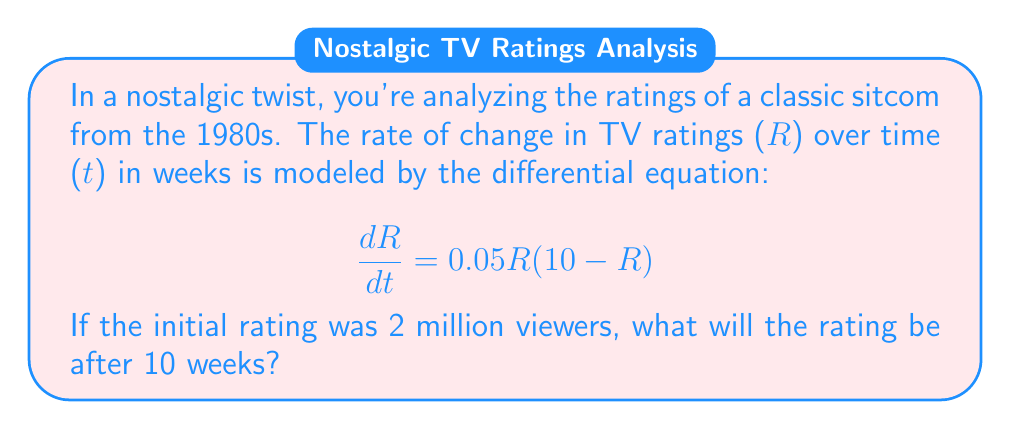Could you help me with this problem? To solve this problem, we need to use the separation of variables method for first-order differential equations. Let's break it down step-by-step:

1) First, we separate the variables:

   $$\frac{dR}{R(10-R)} = 0.05dt$$

2) Integrate both sides:

   $$\int \frac{dR}{R(10-R)} = \int 0.05dt$$

3) The left side can be integrated using partial fractions:

   $$\frac{1}{10}\ln|R| - \frac{1}{10}\ln|10-R| = 0.05t + C$$

4) Simplify:

   $$\ln|\frac{R}{10-R}| = 0.5t + C$$

5) Take the exponential of both sides:

   $$\frac{R}{10-R} = Ae^{0.5t}$$, where $A = e^C$

6) Solve for R:

   $$R = \frac{10Ae^{0.5t}}{1+Ae^{0.5t}}$$

7) Use the initial condition: When $t=0$, $R=2$:

   $$2 = \frac{10A}{1+A}$$

   Solving this, we get $A = \frac{1}{4}$

8) Our final solution is:

   $$R = \frac{10(\frac{1}{4})e^{0.5t}}{1+(\frac{1}{4})e^{0.5t}} = \frac{10e^{0.5t}}{4+e^{0.5t}}$$

9) Now, we can find R when t = 10:

   $$R = \frac{10e^{5}}{4+e^{5}} \approx 9.93$$
Answer: After 10 weeks, the rating will be approximately 9.93 million viewers. 